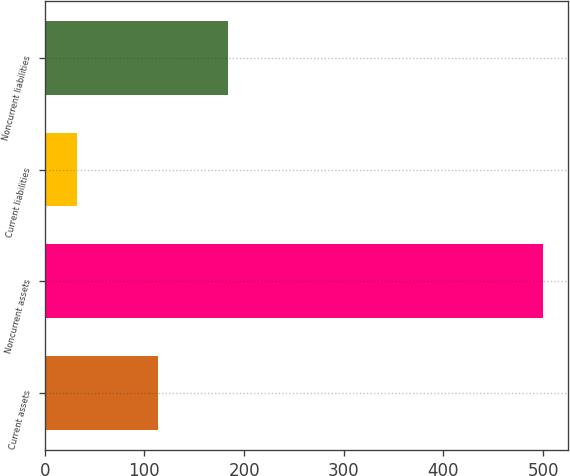Convert chart to OTSL. <chart><loc_0><loc_0><loc_500><loc_500><bar_chart><fcel>Current assets<fcel>Noncurrent assets<fcel>Current liabilities<fcel>Noncurrent liabilities<nl><fcel>114<fcel>500<fcel>32<fcel>184<nl></chart> 